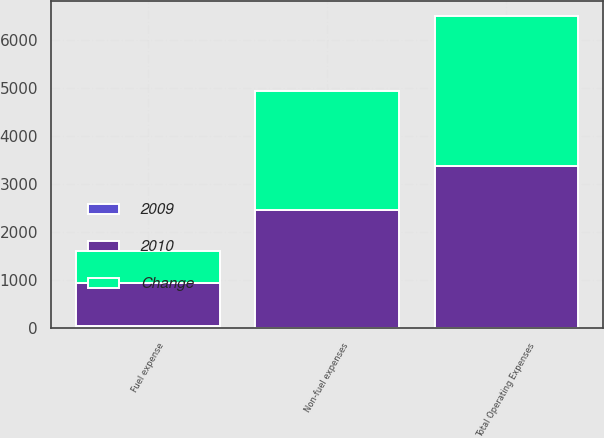Convert chart to OTSL. <chart><loc_0><loc_0><loc_500><loc_500><stacked_bar_chart><ecel><fcel>Fuel expense<fcel>Non-fuel expenses<fcel>Total Operating Expenses<nl><fcel>2010<fcel>900.9<fcel>2459.8<fcel>3360.7<nl><fcel>Change<fcel>658.1<fcel>2474.3<fcel>3132.4<nl><fcel>2009<fcel>36.9<fcel>0.6<fcel>7.3<nl></chart> 